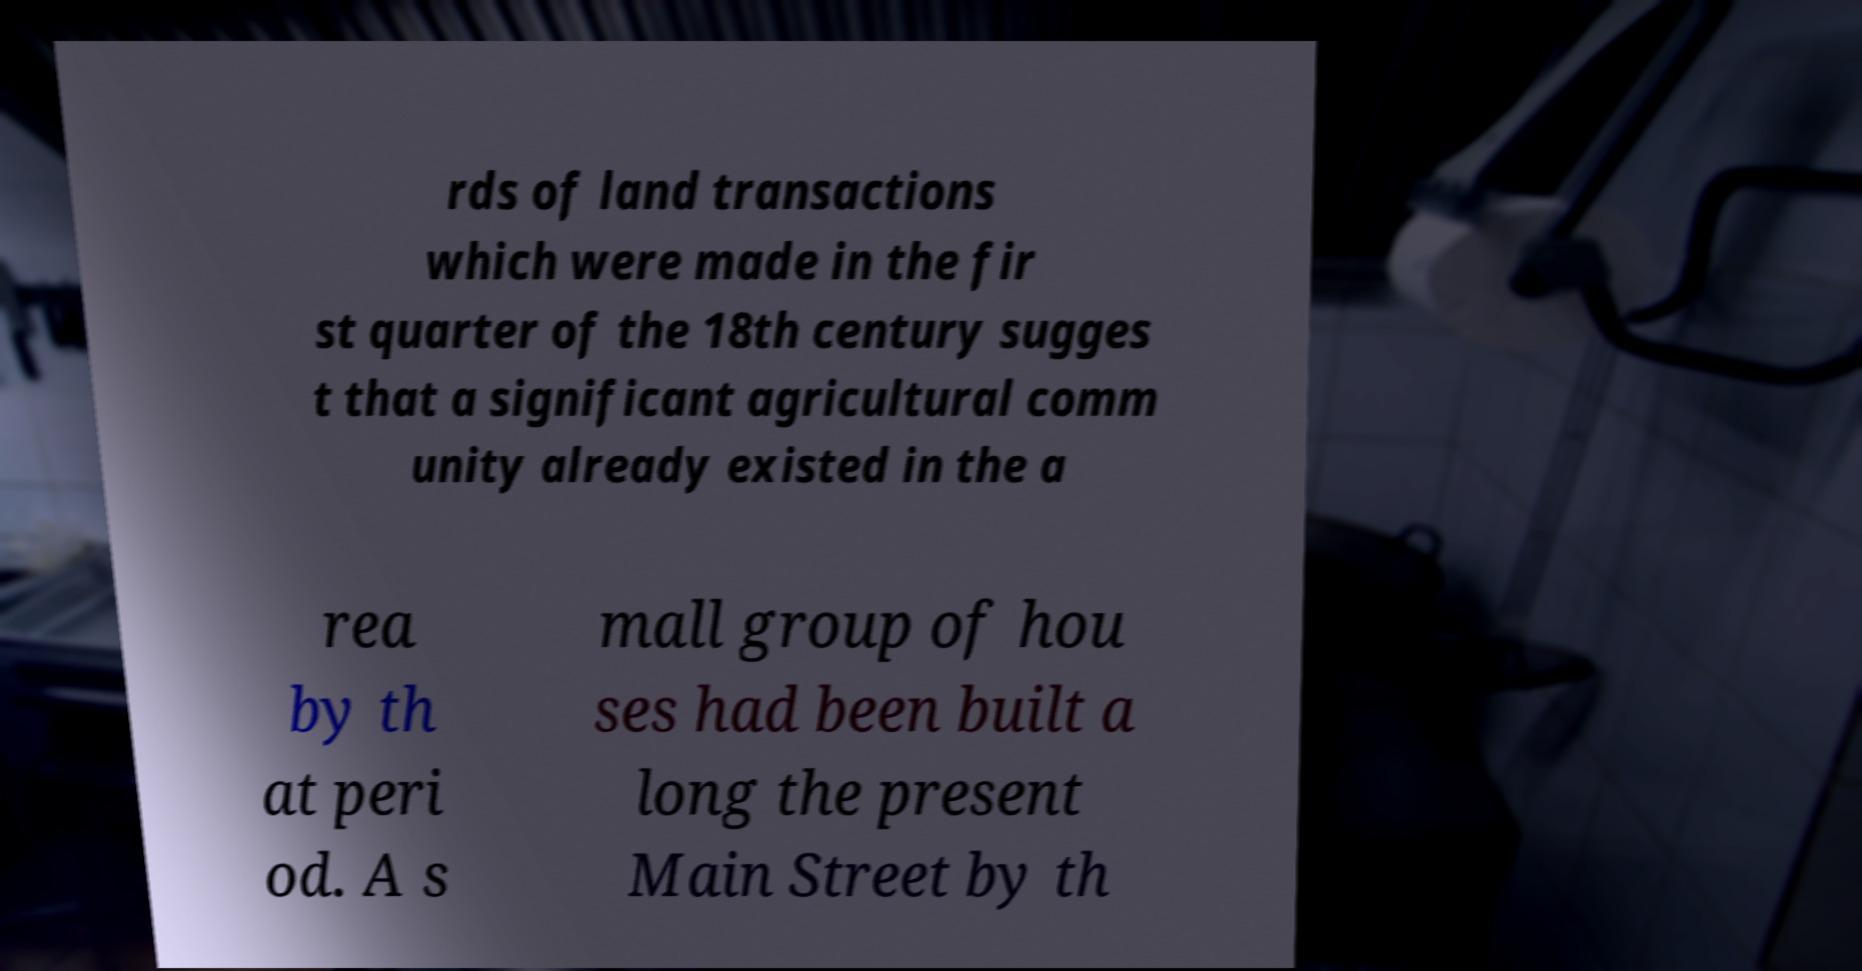Can you accurately transcribe the text from the provided image for me? rds of land transactions which were made in the fir st quarter of the 18th century sugges t that a significant agricultural comm unity already existed in the a rea by th at peri od. A s mall group of hou ses had been built a long the present Main Street by th 